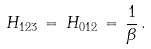<formula> <loc_0><loc_0><loc_500><loc_500>H _ { 1 2 3 } \, = \, H _ { 0 1 2 } \, = \, \frac { 1 } { \beta } \, .</formula> 